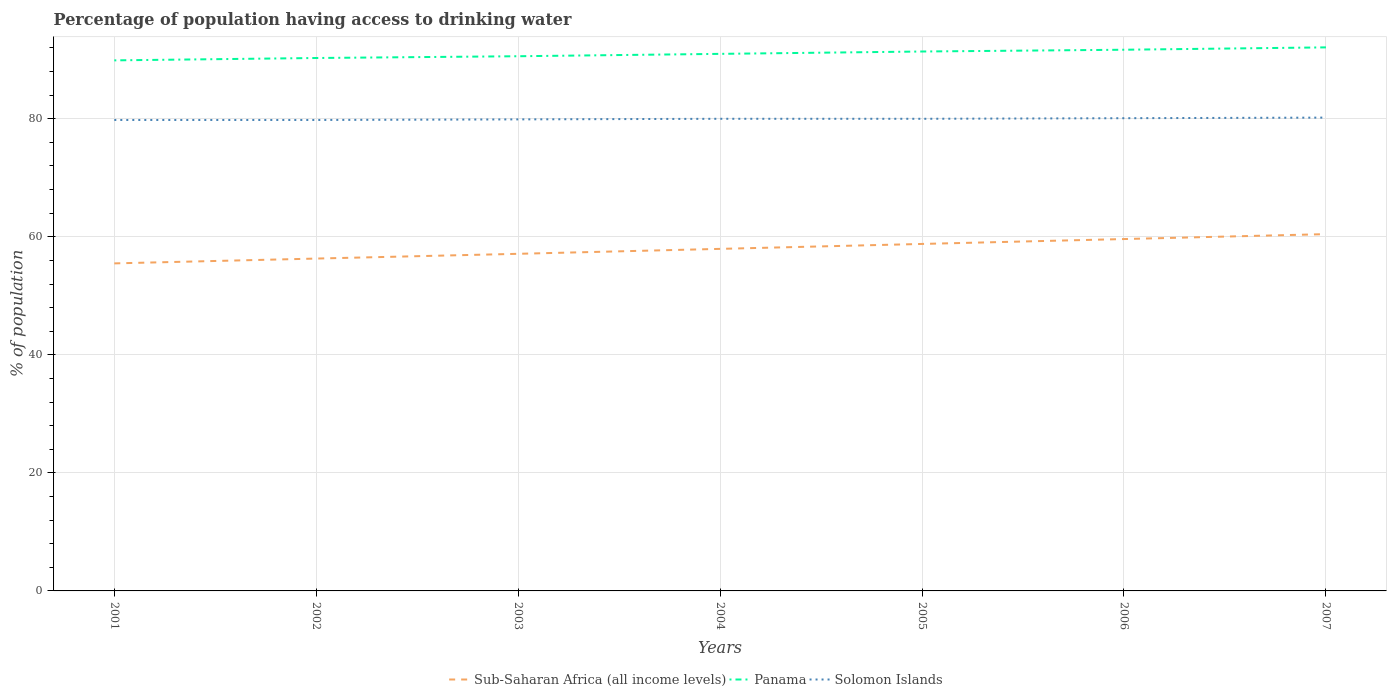Is the number of lines equal to the number of legend labels?
Make the answer very short. Yes. Across all years, what is the maximum percentage of population having access to drinking water in Panama?
Provide a succinct answer. 89.9. What is the total percentage of population having access to drinking water in Sub-Saharan Africa (all income levels) in the graph?
Your answer should be very brief. -2.5. What is the difference between the highest and the second highest percentage of population having access to drinking water in Panama?
Provide a succinct answer. 2.2. What is the difference between the highest and the lowest percentage of population having access to drinking water in Panama?
Your response must be concise. 3. How many lines are there?
Your answer should be compact. 3. How many years are there in the graph?
Offer a terse response. 7. Are the values on the major ticks of Y-axis written in scientific E-notation?
Your answer should be very brief. No. Does the graph contain any zero values?
Ensure brevity in your answer.  No. Where does the legend appear in the graph?
Your answer should be compact. Bottom center. How are the legend labels stacked?
Provide a succinct answer. Horizontal. What is the title of the graph?
Provide a succinct answer. Percentage of population having access to drinking water. What is the label or title of the Y-axis?
Keep it short and to the point. % of population. What is the % of population in Sub-Saharan Africa (all income levels) in 2001?
Your response must be concise. 55.5. What is the % of population in Panama in 2001?
Offer a very short reply. 89.9. What is the % of population in Solomon Islands in 2001?
Offer a terse response. 79.8. What is the % of population of Sub-Saharan Africa (all income levels) in 2002?
Ensure brevity in your answer.  56.32. What is the % of population of Panama in 2002?
Provide a succinct answer. 90.3. What is the % of population of Solomon Islands in 2002?
Keep it short and to the point. 79.8. What is the % of population in Sub-Saharan Africa (all income levels) in 2003?
Your answer should be compact. 57.12. What is the % of population in Panama in 2003?
Give a very brief answer. 90.6. What is the % of population in Solomon Islands in 2003?
Provide a succinct answer. 79.9. What is the % of population in Sub-Saharan Africa (all income levels) in 2004?
Keep it short and to the point. 57.96. What is the % of population in Panama in 2004?
Your response must be concise. 91. What is the % of population of Solomon Islands in 2004?
Keep it short and to the point. 80. What is the % of population of Sub-Saharan Africa (all income levels) in 2005?
Your answer should be compact. 58.79. What is the % of population of Panama in 2005?
Offer a very short reply. 91.4. What is the % of population of Sub-Saharan Africa (all income levels) in 2006?
Give a very brief answer. 59.62. What is the % of population of Panama in 2006?
Make the answer very short. 91.7. What is the % of population in Solomon Islands in 2006?
Offer a terse response. 80.1. What is the % of population in Sub-Saharan Africa (all income levels) in 2007?
Provide a short and direct response. 60.46. What is the % of population in Panama in 2007?
Ensure brevity in your answer.  92.1. What is the % of population in Solomon Islands in 2007?
Your response must be concise. 80.2. Across all years, what is the maximum % of population in Sub-Saharan Africa (all income levels)?
Your answer should be very brief. 60.46. Across all years, what is the maximum % of population in Panama?
Ensure brevity in your answer.  92.1. Across all years, what is the maximum % of population of Solomon Islands?
Provide a short and direct response. 80.2. Across all years, what is the minimum % of population in Sub-Saharan Africa (all income levels)?
Keep it short and to the point. 55.5. Across all years, what is the minimum % of population in Panama?
Ensure brevity in your answer.  89.9. Across all years, what is the minimum % of population of Solomon Islands?
Your answer should be very brief. 79.8. What is the total % of population in Sub-Saharan Africa (all income levels) in the graph?
Make the answer very short. 405.76. What is the total % of population in Panama in the graph?
Give a very brief answer. 637. What is the total % of population in Solomon Islands in the graph?
Give a very brief answer. 559.8. What is the difference between the % of population in Sub-Saharan Africa (all income levels) in 2001 and that in 2002?
Offer a terse response. -0.82. What is the difference between the % of population in Solomon Islands in 2001 and that in 2002?
Keep it short and to the point. 0. What is the difference between the % of population in Sub-Saharan Africa (all income levels) in 2001 and that in 2003?
Make the answer very short. -1.62. What is the difference between the % of population of Sub-Saharan Africa (all income levels) in 2001 and that in 2004?
Offer a very short reply. -2.46. What is the difference between the % of population in Panama in 2001 and that in 2004?
Your answer should be compact. -1.1. What is the difference between the % of population in Sub-Saharan Africa (all income levels) in 2001 and that in 2005?
Keep it short and to the point. -3.3. What is the difference between the % of population of Panama in 2001 and that in 2005?
Your answer should be very brief. -1.5. What is the difference between the % of population of Solomon Islands in 2001 and that in 2005?
Give a very brief answer. -0.2. What is the difference between the % of population of Sub-Saharan Africa (all income levels) in 2001 and that in 2006?
Ensure brevity in your answer.  -4.13. What is the difference between the % of population of Panama in 2001 and that in 2006?
Give a very brief answer. -1.8. What is the difference between the % of population in Sub-Saharan Africa (all income levels) in 2001 and that in 2007?
Provide a short and direct response. -4.96. What is the difference between the % of population of Sub-Saharan Africa (all income levels) in 2002 and that in 2003?
Your response must be concise. -0.81. What is the difference between the % of population of Sub-Saharan Africa (all income levels) in 2002 and that in 2004?
Give a very brief answer. -1.64. What is the difference between the % of population of Solomon Islands in 2002 and that in 2004?
Offer a very short reply. -0.2. What is the difference between the % of population of Sub-Saharan Africa (all income levels) in 2002 and that in 2005?
Offer a very short reply. -2.48. What is the difference between the % of population of Panama in 2002 and that in 2005?
Your answer should be very brief. -1.1. What is the difference between the % of population in Solomon Islands in 2002 and that in 2005?
Your response must be concise. -0.2. What is the difference between the % of population of Sub-Saharan Africa (all income levels) in 2002 and that in 2006?
Keep it short and to the point. -3.31. What is the difference between the % of population in Panama in 2002 and that in 2006?
Your answer should be very brief. -1.4. What is the difference between the % of population in Solomon Islands in 2002 and that in 2006?
Offer a terse response. -0.3. What is the difference between the % of population in Sub-Saharan Africa (all income levels) in 2002 and that in 2007?
Your response must be concise. -4.14. What is the difference between the % of population of Panama in 2002 and that in 2007?
Provide a short and direct response. -1.8. What is the difference between the % of population of Solomon Islands in 2002 and that in 2007?
Provide a short and direct response. -0.4. What is the difference between the % of population in Sub-Saharan Africa (all income levels) in 2003 and that in 2004?
Provide a succinct answer. -0.84. What is the difference between the % of population of Sub-Saharan Africa (all income levels) in 2003 and that in 2005?
Offer a terse response. -1.67. What is the difference between the % of population of Solomon Islands in 2003 and that in 2005?
Provide a succinct answer. -0.1. What is the difference between the % of population of Sub-Saharan Africa (all income levels) in 2003 and that in 2006?
Your answer should be very brief. -2.5. What is the difference between the % of population of Panama in 2003 and that in 2006?
Make the answer very short. -1.1. What is the difference between the % of population of Sub-Saharan Africa (all income levels) in 2003 and that in 2007?
Offer a very short reply. -3.33. What is the difference between the % of population in Solomon Islands in 2003 and that in 2007?
Make the answer very short. -0.3. What is the difference between the % of population of Sub-Saharan Africa (all income levels) in 2004 and that in 2005?
Your response must be concise. -0.84. What is the difference between the % of population in Panama in 2004 and that in 2005?
Provide a succinct answer. -0.4. What is the difference between the % of population of Sub-Saharan Africa (all income levels) in 2004 and that in 2006?
Your answer should be compact. -1.66. What is the difference between the % of population in Panama in 2004 and that in 2006?
Your response must be concise. -0.7. What is the difference between the % of population in Solomon Islands in 2004 and that in 2006?
Offer a very short reply. -0.1. What is the difference between the % of population in Sub-Saharan Africa (all income levels) in 2004 and that in 2007?
Keep it short and to the point. -2.5. What is the difference between the % of population in Panama in 2004 and that in 2007?
Provide a short and direct response. -1.1. What is the difference between the % of population of Sub-Saharan Africa (all income levels) in 2005 and that in 2006?
Provide a short and direct response. -0.83. What is the difference between the % of population of Solomon Islands in 2005 and that in 2006?
Your response must be concise. -0.1. What is the difference between the % of population of Sub-Saharan Africa (all income levels) in 2005 and that in 2007?
Your answer should be compact. -1.66. What is the difference between the % of population of Sub-Saharan Africa (all income levels) in 2006 and that in 2007?
Provide a succinct answer. -0.83. What is the difference between the % of population of Sub-Saharan Africa (all income levels) in 2001 and the % of population of Panama in 2002?
Offer a terse response. -34.8. What is the difference between the % of population in Sub-Saharan Africa (all income levels) in 2001 and the % of population in Solomon Islands in 2002?
Your response must be concise. -24.3. What is the difference between the % of population of Sub-Saharan Africa (all income levels) in 2001 and the % of population of Panama in 2003?
Make the answer very short. -35.1. What is the difference between the % of population in Sub-Saharan Africa (all income levels) in 2001 and the % of population in Solomon Islands in 2003?
Provide a succinct answer. -24.4. What is the difference between the % of population of Sub-Saharan Africa (all income levels) in 2001 and the % of population of Panama in 2004?
Offer a terse response. -35.5. What is the difference between the % of population of Sub-Saharan Africa (all income levels) in 2001 and the % of population of Solomon Islands in 2004?
Your answer should be compact. -24.5. What is the difference between the % of population in Panama in 2001 and the % of population in Solomon Islands in 2004?
Make the answer very short. 9.9. What is the difference between the % of population of Sub-Saharan Africa (all income levels) in 2001 and the % of population of Panama in 2005?
Ensure brevity in your answer.  -35.9. What is the difference between the % of population in Sub-Saharan Africa (all income levels) in 2001 and the % of population in Solomon Islands in 2005?
Your answer should be compact. -24.5. What is the difference between the % of population in Sub-Saharan Africa (all income levels) in 2001 and the % of population in Panama in 2006?
Keep it short and to the point. -36.2. What is the difference between the % of population in Sub-Saharan Africa (all income levels) in 2001 and the % of population in Solomon Islands in 2006?
Provide a short and direct response. -24.6. What is the difference between the % of population in Sub-Saharan Africa (all income levels) in 2001 and the % of population in Panama in 2007?
Offer a terse response. -36.6. What is the difference between the % of population in Sub-Saharan Africa (all income levels) in 2001 and the % of population in Solomon Islands in 2007?
Your answer should be compact. -24.7. What is the difference between the % of population in Panama in 2001 and the % of population in Solomon Islands in 2007?
Your answer should be compact. 9.7. What is the difference between the % of population of Sub-Saharan Africa (all income levels) in 2002 and the % of population of Panama in 2003?
Your answer should be very brief. -34.28. What is the difference between the % of population in Sub-Saharan Africa (all income levels) in 2002 and the % of population in Solomon Islands in 2003?
Offer a very short reply. -23.58. What is the difference between the % of population of Sub-Saharan Africa (all income levels) in 2002 and the % of population of Panama in 2004?
Provide a succinct answer. -34.68. What is the difference between the % of population in Sub-Saharan Africa (all income levels) in 2002 and the % of population in Solomon Islands in 2004?
Provide a short and direct response. -23.68. What is the difference between the % of population of Panama in 2002 and the % of population of Solomon Islands in 2004?
Offer a very short reply. 10.3. What is the difference between the % of population of Sub-Saharan Africa (all income levels) in 2002 and the % of population of Panama in 2005?
Provide a succinct answer. -35.08. What is the difference between the % of population of Sub-Saharan Africa (all income levels) in 2002 and the % of population of Solomon Islands in 2005?
Provide a short and direct response. -23.68. What is the difference between the % of population in Sub-Saharan Africa (all income levels) in 2002 and the % of population in Panama in 2006?
Ensure brevity in your answer.  -35.38. What is the difference between the % of population in Sub-Saharan Africa (all income levels) in 2002 and the % of population in Solomon Islands in 2006?
Provide a succinct answer. -23.78. What is the difference between the % of population in Sub-Saharan Africa (all income levels) in 2002 and the % of population in Panama in 2007?
Offer a terse response. -35.78. What is the difference between the % of population of Sub-Saharan Africa (all income levels) in 2002 and the % of population of Solomon Islands in 2007?
Your answer should be compact. -23.88. What is the difference between the % of population of Panama in 2002 and the % of population of Solomon Islands in 2007?
Your answer should be very brief. 10.1. What is the difference between the % of population of Sub-Saharan Africa (all income levels) in 2003 and the % of population of Panama in 2004?
Offer a very short reply. -33.88. What is the difference between the % of population of Sub-Saharan Africa (all income levels) in 2003 and the % of population of Solomon Islands in 2004?
Ensure brevity in your answer.  -22.88. What is the difference between the % of population of Panama in 2003 and the % of population of Solomon Islands in 2004?
Your response must be concise. 10.6. What is the difference between the % of population in Sub-Saharan Africa (all income levels) in 2003 and the % of population in Panama in 2005?
Ensure brevity in your answer.  -34.28. What is the difference between the % of population in Sub-Saharan Africa (all income levels) in 2003 and the % of population in Solomon Islands in 2005?
Ensure brevity in your answer.  -22.88. What is the difference between the % of population in Sub-Saharan Africa (all income levels) in 2003 and the % of population in Panama in 2006?
Keep it short and to the point. -34.58. What is the difference between the % of population of Sub-Saharan Africa (all income levels) in 2003 and the % of population of Solomon Islands in 2006?
Your response must be concise. -22.98. What is the difference between the % of population of Panama in 2003 and the % of population of Solomon Islands in 2006?
Your answer should be very brief. 10.5. What is the difference between the % of population in Sub-Saharan Africa (all income levels) in 2003 and the % of population in Panama in 2007?
Your answer should be very brief. -34.98. What is the difference between the % of population in Sub-Saharan Africa (all income levels) in 2003 and the % of population in Solomon Islands in 2007?
Provide a succinct answer. -23.08. What is the difference between the % of population in Sub-Saharan Africa (all income levels) in 2004 and the % of population in Panama in 2005?
Your response must be concise. -33.44. What is the difference between the % of population in Sub-Saharan Africa (all income levels) in 2004 and the % of population in Solomon Islands in 2005?
Ensure brevity in your answer.  -22.04. What is the difference between the % of population of Panama in 2004 and the % of population of Solomon Islands in 2005?
Keep it short and to the point. 11. What is the difference between the % of population of Sub-Saharan Africa (all income levels) in 2004 and the % of population of Panama in 2006?
Ensure brevity in your answer.  -33.74. What is the difference between the % of population of Sub-Saharan Africa (all income levels) in 2004 and the % of population of Solomon Islands in 2006?
Keep it short and to the point. -22.14. What is the difference between the % of population in Panama in 2004 and the % of population in Solomon Islands in 2006?
Make the answer very short. 10.9. What is the difference between the % of population of Sub-Saharan Africa (all income levels) in 2004 and the % of population of Panama in 2007?
Keep it short and to the point. -34.14. What is the difference between the % of population in Sub-Saharan Africa (all income levels) in 2004 and the % of population in Solomon Islands in 2007?
Give a very brief answer. -22.24. What is the difference between the % of population in Panama in 2004 and the % of population in Solomon Islands in 2007?
Your answer should be compact. 10.8. What is the difference between the % of population in Sub-Saharan Africa (all income levels) in 2005 and the % of population in Panama in 2006?
Ensure brevity in your answer.  -32.91. What is the difference between the % of population in Sub-Saharan Africa (all income levels) in 2005 and the % of population in Solomon Islands in 2006?
Give a very brief answer. -21.31. What is the difference between the % of population of Panama in 2005 and the % of population of Solomon Islands in 2006?
Give a very brief answer. 11.3. What is the difference between the % of population in Sub-Saharan Africa (all income levels) in 2005 and the % of population in Panama in 2007?
Provide a short and direct response. -33.31. What is the difference between the % of population in Sub-Saharan Africa (all income levels) in 2005 and the % of population in Solomon Islands in 2007?
Ensure brevity in your answer.  -21.41. What is the difference between the % of population of Panama in 2005 and the % of population of Solomon Islands in 2007?
Offer a terse response. 11.2. What is the difference between the % of population in Sub-Saharan Africa (all income levels) in 2006 and the % of population in Panama in 2007?
Give a very brief answer. -32.48. What is the difference between the % of population of Sub-Saharan Africa (all income levels) in 2006 and the % of population of Solomon Islands in 2007?
Offer a very short reply. -20.58. What is the difference between the % of population in Panama in 2006 and the % of population in Solomon Islands in 2007?
Provide a succinct answer. 11.5. What is the average % of population of Sub-Saharan Africa (all income levels) per year?
Give a very brief answer. 57.97. What is the average % of population in Panama per year?
Your response must be concise. 91. What is the average % of population of Solomon Islands per year?
Your answer should be very brief. 79.97. In the year 2001, what is the difference between the % of population in Sub-Saharan Africa (all income levels) and % of population in Panama?
Offer a very short reply. -34.4. In the year 2001, what is the difference between the % of population in Sub-Saharan Africa (all income levels) and % of population in Solomon Islands?
Give a very brief answer. -24.3. In the year 2001, what is the difference between the % of population in Panama and % of population in Solomon Islands?
Keep it short and to the point. 10.1. In the year 2002, what is the difference between the % of population in Sub-Saharan Africa (all income levels) and % of population in Panama?
Your answer should be compact. -33.98. In the year 2002, what is the difference between the % of population in Sub-Saharan Africa (all income levels) and % of population in Solomon Islands?
Your response must be concise. -23.48. In the year 2003, what is the difference between the % of population of Sub-Saharan Africa (all income levels) and % of population of Panama?
Your response must be concise. -33.48. In the year 2003, what is the difference between the % of population in Sub-Saharan Africa (all income levels) and % of population in Solomon Islands?
Keep it short and to the point. -22.78. In the year 2003, what is the difference between the % of population in Panama and % of population in Solomon Islands?
Provide a short and direct response. 10.7. In the year 2004, what is the difference between the % of population of Sub-Saharan Africa (all income levels) and % of population of Panama?
Your response must be concise. -33.04. In the year 2004, what is the difference between the % of population in Sub-Saharan Africa (all income levels) and % of population in Solomon Islands?
Keep it short and to the point. -22.04. In the year 2005, what is the difference between the % of population of Sub-Saharan Africa (all income levels) and % of population of Panama?
Provide a short and direct response. -32.61. In the year 2005, what is the difference between the % of population in Sub-Saharan Africa (all income levels) and % of population in Solomon Islands?
Offer a very short reply. -21.21. In the year 2005, what is the difference between the % of population of Panama and % of population of Solomon Islands?
Make the answer very short. 11.4. In the year 2006, what is the difference between the % of population in Sub-Saharan Africa (all income levels) and % of population in Panama?
Provide a succinct answer. -32.08. In the year 2006, what is the difference between the % of population of Sub-Saharan Africa (all income levels) and % of population of Solomon Islands?
Provide a succinct answer. -20.48. In the year 2007, what is the difference between the % of population of Sub-Saharan Africa (all income levels) and % of population of Panama?
Give a very brief answer. -31.64. In the year 2007, what is the difference between the % of population in Sub-Saharan Africa (all income levels) and % of population in Solomon Islands?
Offer a very short reply. -19.74. In the year 2007, what is the difference between the % of population in Panama and % of population in Solomon Islands?
Offer a very short reply. 11.9. What is the ratio of the % of population in Sub-Saharan Africa (all income levels) in 2001 to that in 2002?
Your answer should be very brief. 0.99. What is the ratio of the % of population of Panama in 2001 to that in 2002?
Your answer should be very brief. 1. What is the ratio of the % of population of Sub-Saharan Africa (all income levels) in 2001 to that in 2003?
Your answer should be very brief. 0.97. What is the ratio of the % of population in Panama in 2001 to that in 2003?
Provide a succinct answer. 0.99. What is the ratio of the % of population of Solomon Islands in 2001 to that in 2003?
Give a very brief answer. 1. What is the ratio of the % of population of Sub-Saharan Africa (all income levels) in 2001 to that in 2004?
Give a very brief answer. 0.96. What is the ratio of the % of population of Panama in 2001 to that in 2004?
Offer a terse response. 0.99. What is the ratio of the % of population of Sub-Saharan Africa (all income levels) in 2001 to that in 2005?
Your answer should be very brief. 0.94. What is the ratio of the % of population of Panama in 2001 to that in 2005?
Make the answer very short. 0.98. What is the ratio of the % of population in Solomon Islands in 2001 to that in 2005?
Provide a succinct answer. 1. What is the ratio of the % of population of Sub-Saharan Africa (all income levels) in 2001 to that in 2006?
Keep it short and to the point. 0.93. What is the ratio of the % of population in Panama in 2001 to that in 2006?
Offer a terse response. 0.98. What is the ratio of the % of population in Sub-Saharan Africa (all income levels) in 2001 to that in 2007?
Ensure brevity in your answer.  0.92. What is the ratio of the % of population in Panama in 2001 to that in 2007?
Keep it short and to the point. 0.98. What is the ratio of the % of population of Solomon Islands in 2001 to that in 2007?
Provide a succinct answer. 0.99. What is the ratio of the % of population of Sub-Saharan Africa (all income levels) in 2002 to that in 2003?
Offer a terse response. 0.99. What is the ratio of the % of population of Panama in 2002 to that in 2003?
Make the answer very short. 1. What is the ratio of the % of population of Solomon Islands in 2002 to that in 2003?
Give a very brief answer. 1. What is the ratio of the % of population of Sub-Saharan Africa (all income levels) in 2002 to that in 2004?
Provide a short and direct response. 0.97. What is the ratio of the % of population of Panama in 2002 to that in 2004?
Keep it short and to the point. 0.99. What is the ratio of the % of population in Solomon Islands in 2002 to that in 2004?
Your answer should be very brief. 1. What is the ratio of the % of population in Sub-Saharan Africa (all income levels) in 2002 to that in 2005?
Your response must be concise. 0.96. What is the ratio of the % of population of Panama in 2002 to that in 2005?
Your response must be concise. 0.99. What is the ratio of the % of population in Solomon Islands in 2002 to that in 2005?
Your response must be concise. 1. What is the ratio of the % of population in Sub-Saharan Africa (all income levels) in 2002 to that in 2006?
Your answer should be very brief. 0.94. What is the ratio of the % of population in Panama in 2002 to that in 2006?
Offer a terse response. 0.98. What is the ratio of the % of population of Sub-Saharan Africa (all income levels) in 2002 to that in 2007?
Offer a terse response. 0.93. What is the ratio of the % of population in Panama in 2002 to that in 2007?
Keep it short and to the point. 0.98. What is the ratio of the % of population of Sub-Saharan Africa (all income levels) in 2003 to that in 2004?
Offer a very short reply. 0.99. What is the ratio of the % of population in Panama in 2003 to that in 2004?
Offer a terse response. 1. What is the ratio of the % of population of Sub-Saharan Africa (all income levels) in 2003 to that in 2005?
Provide a succinct answer. 0.97. What is the ratio of the % of population of Sub-Saharan Africa (all income levels) in 2003 to that in 2006?
Keep it short and to the point. 0.96. What is the ratio of the % of population in Sub-Saharan Africa (all income levels) in 2003 to that in 2007?
Your answer should be very brief. 0.94. What is the ratio of the % of population of Panama in 2003 to that in 2007?
Offer a terse response. 0.98. What is the ratio of the % of population of Solomon Islands in 2003 to that in 2007?
Offer a very short reply. 1. What is the ratio of the % of population in Sub-Saharan Africa (all income levels) in 2004 to that in 2005?
Offer a terse response. 0.99. What is the ratio of the % of population of Panama in 2004 to that in 2005?
Offer a very short reply. 1. What is the ratio of the % of population in Solomon Islands in 2004 to that in 2005?
Provide a short and direct response. 1. What is the ratio of the % of population of Sub-Saharan Africa (all income levels) in 2004 to that in 2006?
Provide a succinct answer. 0.97. What is the ratio of the % of population of Solomon Islands in 2004 to that in 2006?
Give a very brief answer. 1. What is the ratio of the % of population in Sub-Saharan Africa (all income levels) in 2004 to that in 2007?
Provide a succinct answer. 0.96. What is the ratio of the % of population in Solomon Islands in 2004 to that in 2007?
Keep it short and to the point. 1. What is the ratio of the % of population in Sub-Saharan Africa (all income levels) in 2005 to that in 2006?
Your answer should be compact. 0.99. What is the ratio of the % of population in Panama in 2005 to that in 2006?
Your answer should be very brief. 1. What is the ratio of the % of population of Sub-Saharan Africa (all income levels) in 2005 to that in 2007?
Your answer should be compact. 0.97. What is the ratio of the % of population of Sub-Saharan Africa (all income levels) in 2006 to that in 2007?
Your answer should be compact. 0.99. What is the ratio of the % of population in Panama in 2006 to that in 2007?
Give a very brief answer. 1. What is the ratio of the % of population of Solomon Islands in 2006 to that in 2007?
Your response must be concise. 1. What is the difference between the highest and the second highest % of population in Sub-Saharan Africa (all income levels)?
Make the answer very short. 0.83. What is the difference between the highest and the lowest % of population of Sub-Saharan Africa (all income levels)?
Offer a terse response. 4.96. What is the difference between the highest and the lowest % of population in Panama?
Your answer should be compact. 2.2. What is the difference between the highest and the lowest % of population of Solomon Islands?
Make the answer very short. 0.4. 